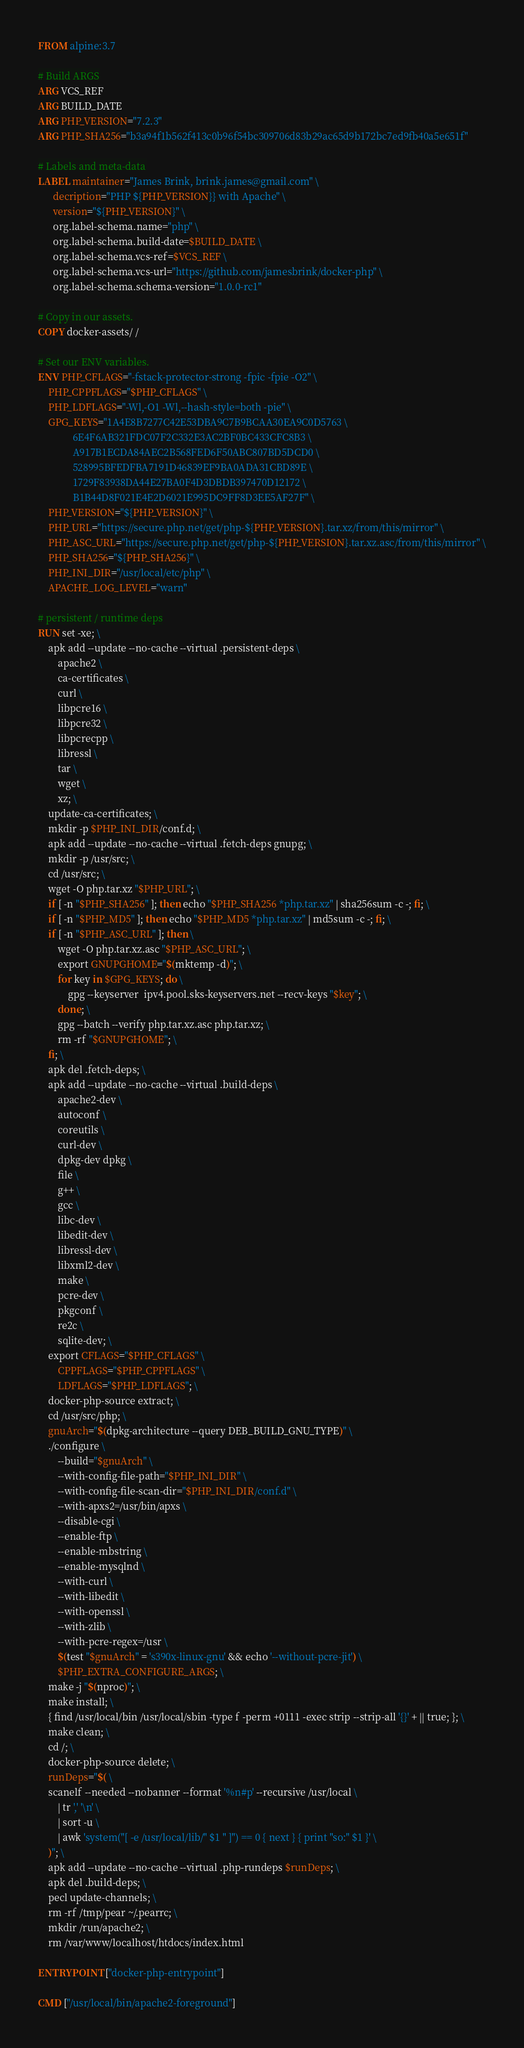Convert code to text. <code><loc_0><loc_0><loc_500><loc_500><_Dockerfile_>FROM alpine:3.7

# Build ARGS
ARG VCS_REF
ARG BUILD_DATE
ARG PHP_VERSION="7.2.3"
ARG PHP_SHA256="b3a94f1b562f413c0b96f54bc309706d83b29ac65d9b172bc7ed9fb40a5e651f"

# Labels and meta-data
LABEL maintainer="James Brink, brink.james@gmail.com" \
      decription="PHP ${PHP_VERSION}} with Apache" \
      version="${PHP_VERSION}" \
      org.label-schema.name="php" \
      org.label-schema.build-date=$BUILD_DATE \
      org.label-schema.vcs-ref=$VCS_REF \
      org.label-schema.vcs-url="https://github.com/jamesbrink/docker-php" \
      org.label-schema.schema-version="1.0.0-rc1"

# Copy in our assets.
COPY docker-assets/ /

# Set our ENV variables.
ENV PHP_CFLAGS="-fstack-protector-strong -fpic -fpie -O2" \
    PHP_CPPFLAGS="$PHP_CFLAGS" \
    PHP_LDFLAGS="-Wl,-O1 -Wl,--hash-style=both -pie" \
    GPG_KEYS="1A4E8B7277C42E53DBA9C7B9BCAA30EA9C0D5763 \
              6E4F6AB321FDC07F2C332E3AC2BF0BC433CFC8B3 \
              A917B1ECDA84AEC2B568FED6F50ABC807BD5DCD0 \
              528995BFEDFBA7191D46839EF9BA0ADA31CBD89E \
              1729F83938DA44E27BA0F4D3DBDB397470D12172 \
              B1B44D8F021E4E2D6021E995DC9FF8D3EE5AF27F" \
    PHP_VERSION="${PHP_VERSION}" \
    PHP_URL="https://secure.php.net/get/php-${PHP_VERSION}.tar.xz/from/this/mirror" \
    PHP_ASC_URL="https://secure.php.net/get/php-${PHP_VERSION}.tar.xz.asc/from/this/mirror" \
    PHP_SHA256="${PHP_SHA256}" \
    PHP_INI_DIR="/usr/local/etc/php" \
    APACHE_LOG_LEVEL="warn"

# persistent / runtime deps
RUN set -xe; \
    apk add --update --no-cache --virtual .persistent-deps \
        apache2 \
        ca-certificates \
        curl \
        libpcre16 \
        libpcre32 \
        libpcrecpp \
        libressl \
        tar \
        wget \
        xz; \
    update-ca-certificates; \
    mkdir -p $PHP_INI_DIR/conf.d; \
    apk add --update --no-cache --virtual .fetch-deps gnupg; \
    mkdir -p /usr/src; \
    cd /usr/src; \
    wget -O php.tar.xz "$PHP_URL"; \
    if [ -n "$PHP_SHA256" ]; then echo "$PHP_SHA256 *php.tar.xz" | sha256sum -c -; fi; \
    if [ -n "$PHP_MD5" ]; then echo "$PHP_MD5 *php.tar.xz" | md5sum -c -; fi; \
    if [ -n "$PHP_ASC_URL" ]; then \
        wget -O php.tar.xz.asc "$PHP_ASC_URL"; \
        export GNUPGHOME="$(mktemp -d)"; \
        for key in $GPG_KEYS; do \
            gpg --keyserver  ipv4.pool.sks-keyservers.net --recv-keys "$key"; \
        done; \
        gpg --batch --verify php.tar.xz.asc php.tar.xz; \
        rm -rf "$GNUPGHOME"; \
    fi; \
    apk del .fetch-deps; \
    apk add --update --no-cache --virtual .build-deps \
        apache2-dev \
        autoconf \
        coreutils \
        curl-dev \
        dpkg-dev dpkg \
        file \
        g++ \
        gcc \
        libc-dev \
        libedit-dev \
        libressl-dev \
        libxml2-dev \
        make \
        pcre-dev \
        pkgconf \
        re2c \
        sqlite-dev; \
    export CFLAGS="$PHP_CFLAGS" \
        CPPFLAGS="$PHP_CPPFLAGS" \
        LDFLAGS="$PHP_LDFLAGS"; \
    docker-php-source extract; \
    cd /usr/src/php; \
    gnuArch="$(dpkg-architecture --query DEB_BUILD_GNU_TYPE)" \
    ./configure \
        --build="$gnuArch" \
        --with-config-file-path="$PHP_INI_DIR" \
        --with-config-file-scan-dir="$PHP_INI_DIR/conf.d" \
        --with-apxs2=/usr/bin/apxs \
        --disable-cgi \
        --enable-ftp \
        --enable-mbstring \
        --enable-mysqlnd \
        --with-curl \
        --with-libedit \
        --with-openssl \
        --with-zlib \
        --with-pcre-regex=/usr \
        $(test "$gnuArch" = 's390x-linux-gnu' && echo '--without-pcre-jit') \
        $PHP_EXTRA_CONFIGURE_ARGS; \
    make -j "$(nproc)"; \
    make install; \
    { find /usr/local/bin /usr/local/sbin -type f -perm +0111 -exec strip --strip-all '{}' + || true; }; \
    make clean; \
    cd /; \
    docker-php-source delete; \
    runDeps="$( \
    scanelf --needed --nobanner --format '%n#p' --recursive /usr/local \
      	| tr ',' '\n' \
      	| sort -u \
      	| awk 'system("[ -e /usr/local/lib/" $1 " ]") == 0 { next } { print "so:" $1 }' \
    )"; \
    apk add --update --no-cache --virtual .php-rundeps $runDeps; \
    apk del .build-deps; \
    pecl update-channels; \
    rm -rf /tmp/pear ~/.pearrc; \
    mkdir /run/apache2; \
    rm /var/www/localhost/htdocs/index.html

ENTRYPOINT ["docker-php-entrypoint"]

CMD ["/usr/local/bin/apache2-foreground"]
</code> 